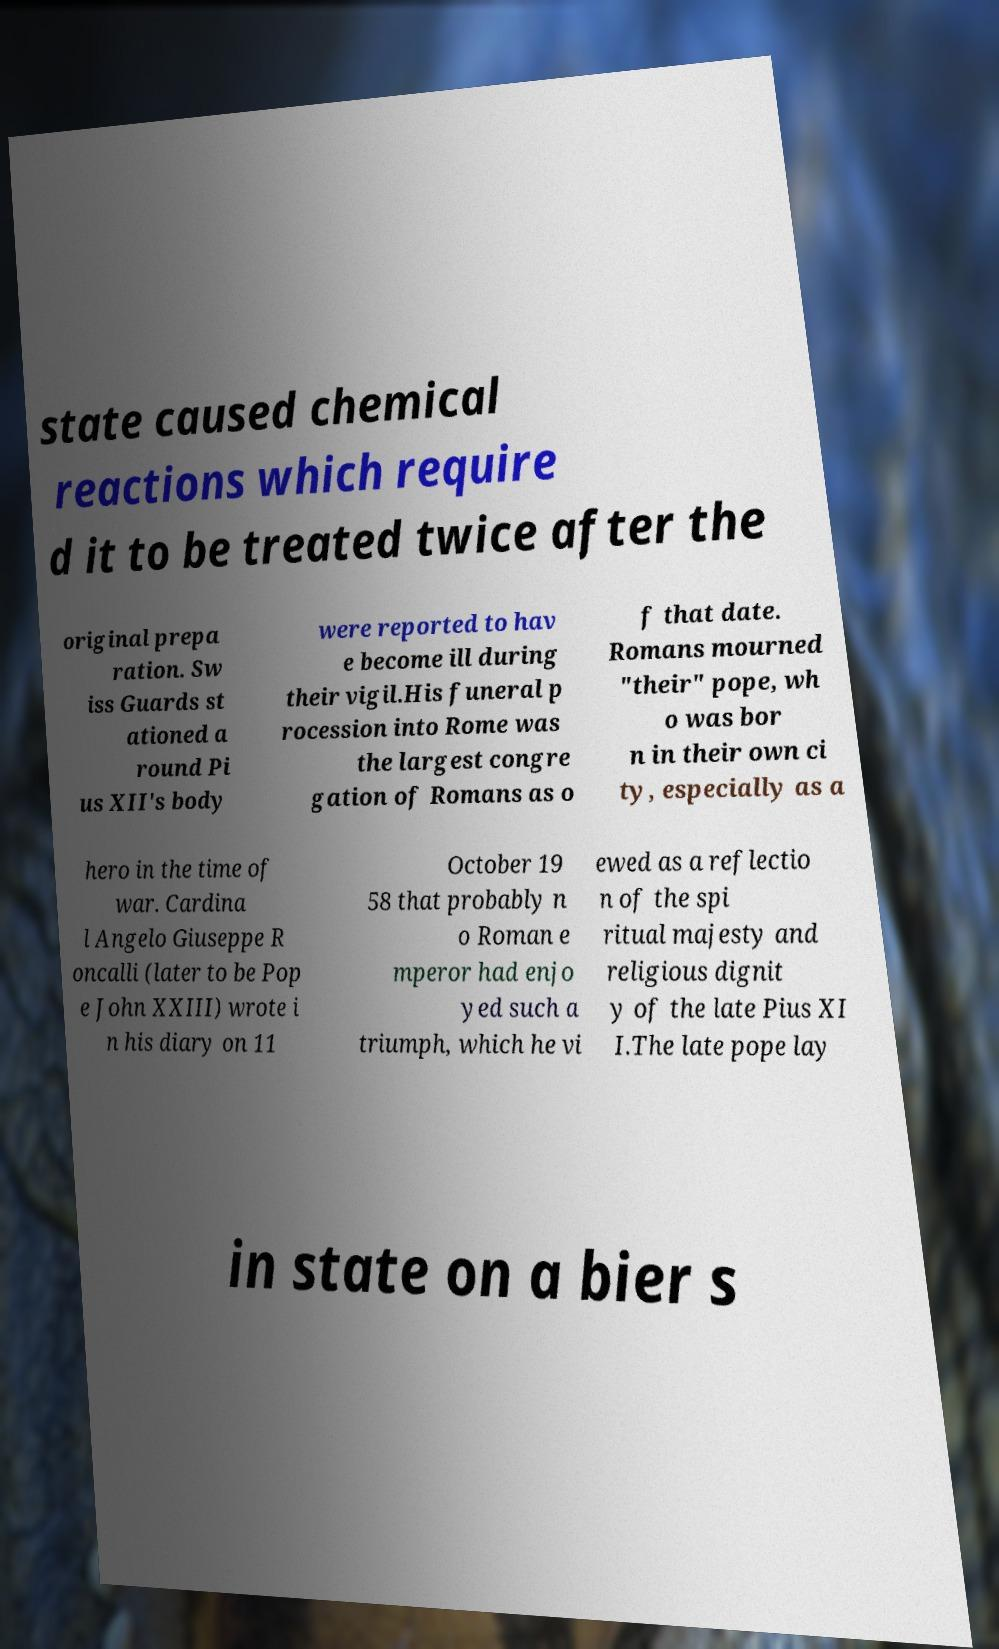Could you extract and type out the text from this image? state caused chemical reactions which require d it to be treated twice after the original prepa ration. Sw iss Guards st ationed a round Pi us XII's body were reported to hav e become ill during their vigil.His funeral p rocession into Rome was the largest congre gation of Romans as o f that date. Romans mourned "their" pope, wh o was bor n in their own ci ty, especially as a hero in the time of war. Cardina l Angelo Giuseppe R oncalli (later to be Pop e John XXIII) wrote i n his diary on 11 October 19 58 that probably n o Roman e mperor had enjo yed such a triumph, which he vi ewed as a reflectio n of the spi ritual majesty and religious dignit y of the late Pius XI I.The late pope lay in state on a bier s 